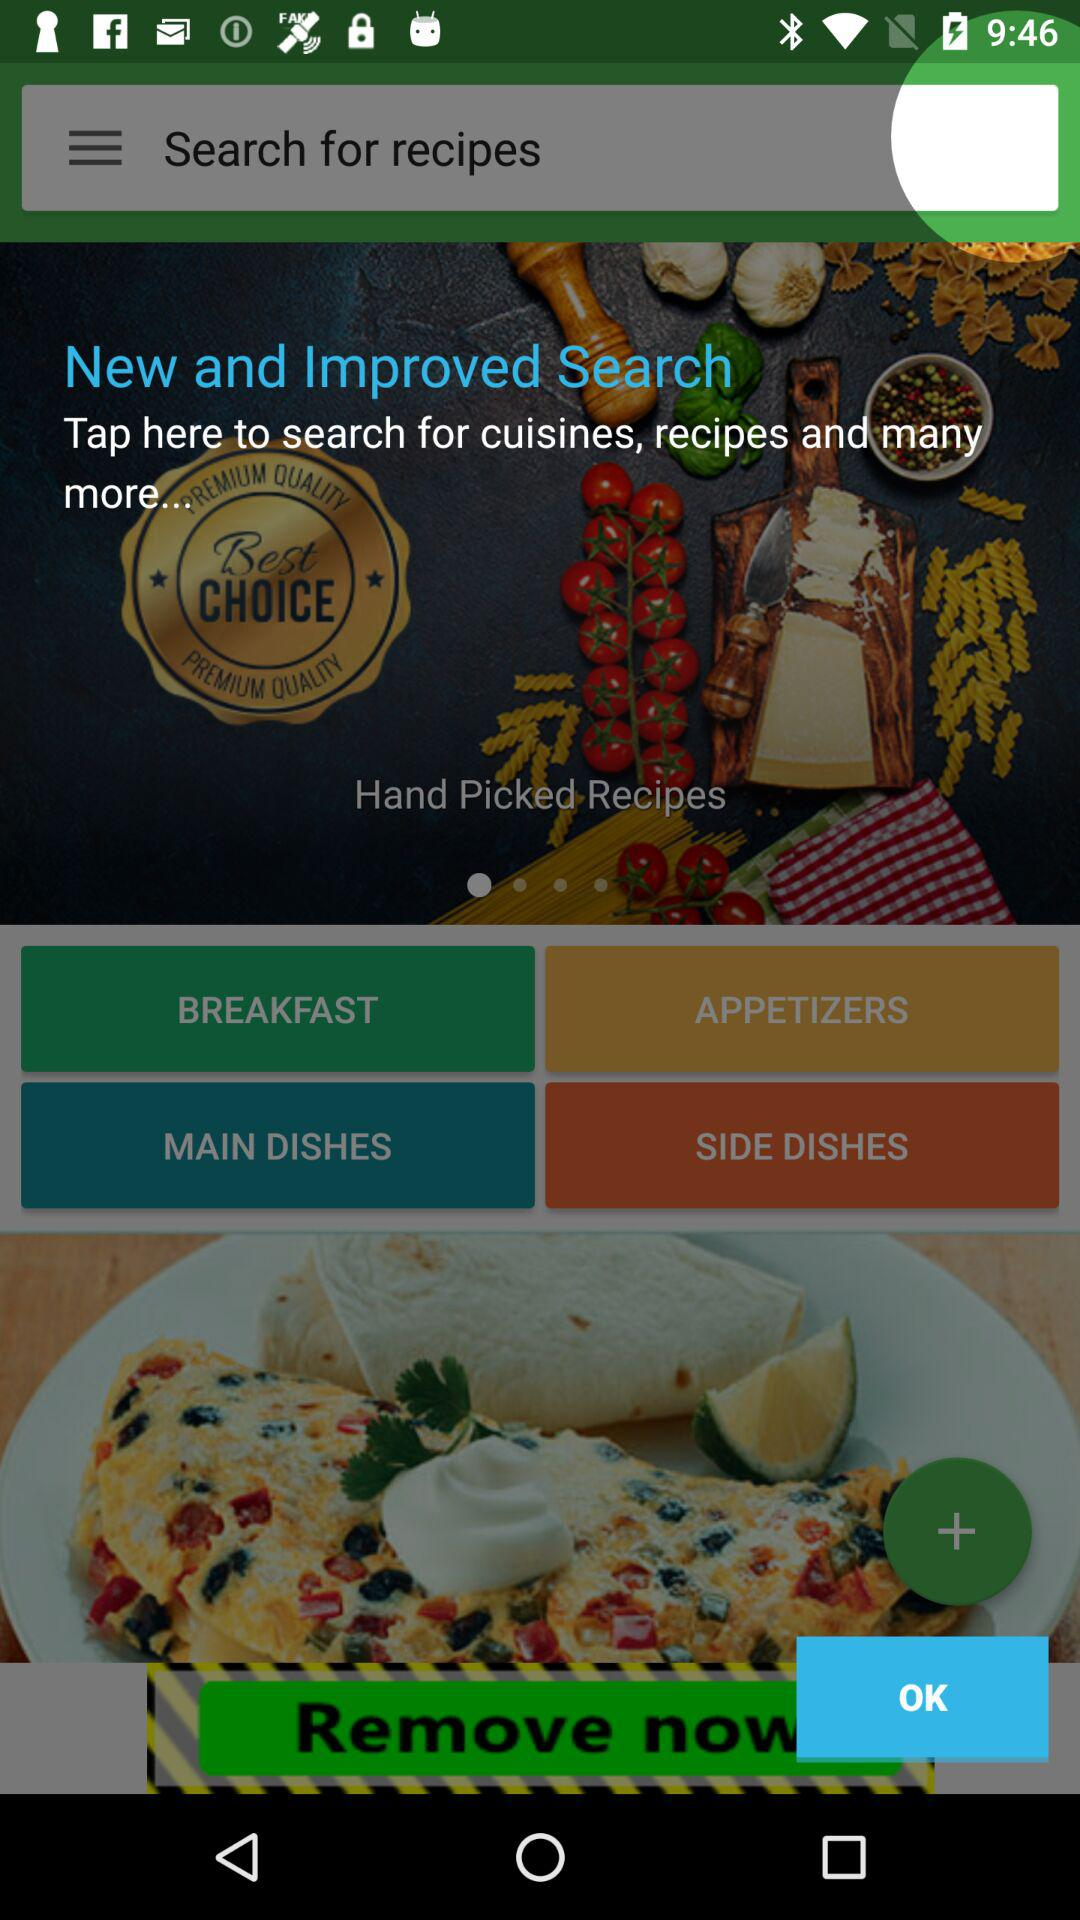What are the different categories of recipes available?
When the provided information is insufficient, respond with <no answer>. <no answer> 